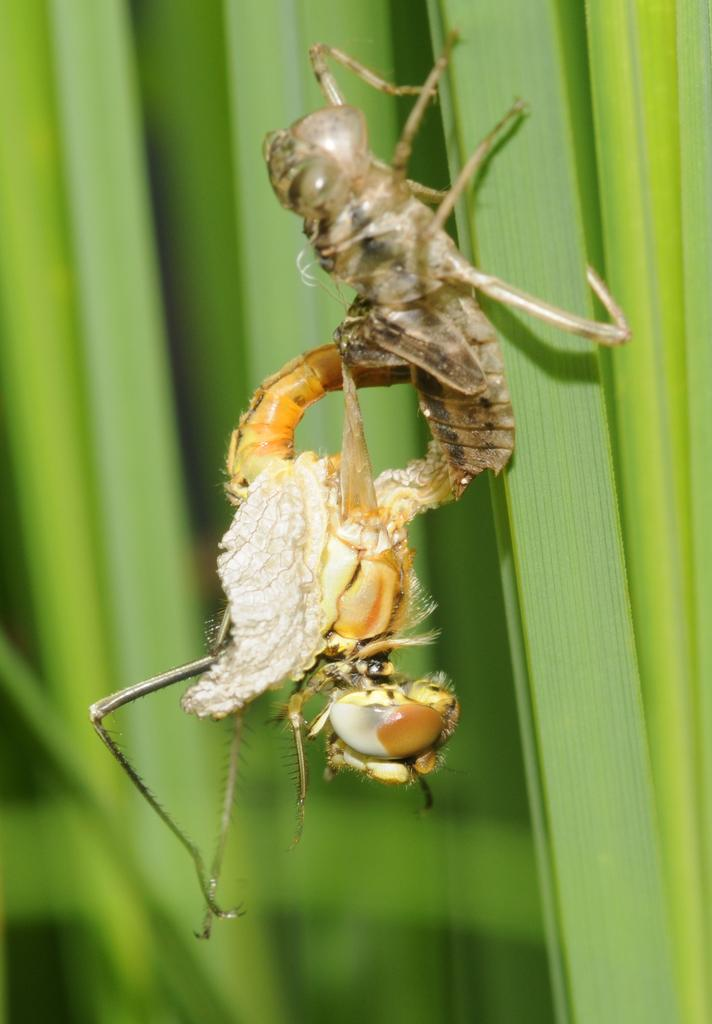How many insects are present in the image? There are two insects in the image. Where are the insects located? The insects are on a plant. What type of environment might the image have been taken in? The image may have been taken in a garden. When was the image likely taken? The image was likely taken during the day. What type of throne can be seen in the image? There is no throne present in the image; it features two insects on a plant. What type of breakfast is being served in the image? There is no breakfast being served in the image; it only shows insects on a plant. 